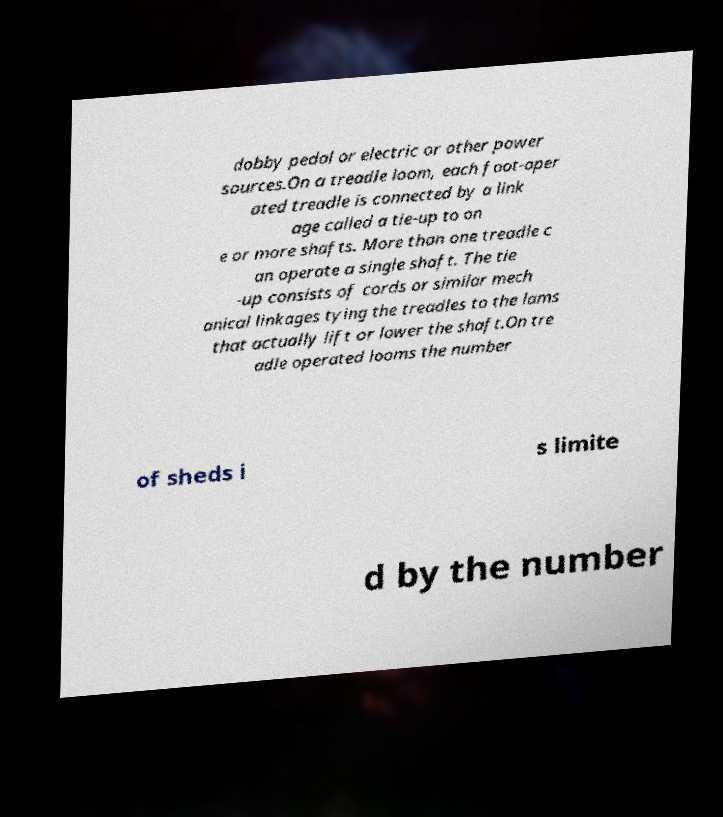Can you accurately transcribe the text from the provided image for me? dobby pedal or electric or other power sources.On a treadle loom, each foot-oper ated treadle is connected by a link age called a tie-up to on e or more shafts. More than one treadle c an operate a single shaft. The tie -up consists of cords or similar mech anical linkages tying the treadles to the lams that actually lift or lower the shaft.On tre adle operated looms the number of sheds i s limite d by the number 